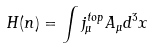<formula> <loc_0><loc_0><loc_500><loc_500>H ( n ) = \int j _ { \mu } ^ { t o p } A _ { \mu } d ^ { 3 } x</formula> 